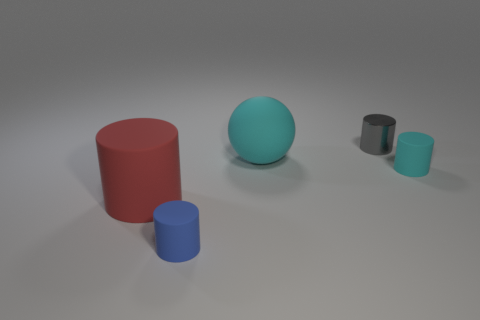Add 2 tiny red spheres. How many objects exist? 7 Subtract all red cylinders. How many cylinders are left? 3 Subtract all matte cylinders. How many cylinders are left? 1 Subtract all gray cylinders. How many brown spheres are left? 0 Subtract 1 blue cylinders. How many objects are left? 4 Subtract all balls. How many objects are left? 4 Subtract 2 cylinders. How many cylinders are left? 2 Subtract all gray cylinders. Subtract all yellow balls. How many cylinders are left? 3 Subtract all large red matte cylinders. Subtract all cyan balls. How many objects are left? 3 Add 1 gray metal cylinders. How many gray metal cylinders are left? 2 